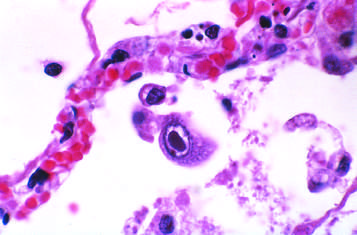do infected cells show distinct nuclear inclusions?
Answer the question using a single word or phrase. Yes 